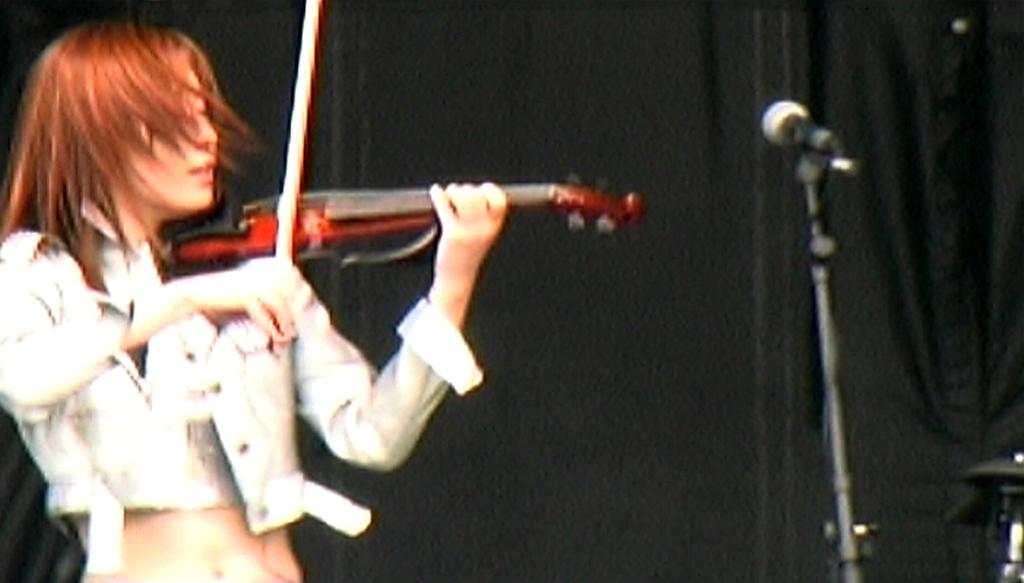What is the main subject of the image? There is a person in the image. Where is the person located in the image? The person is standing on the left side of the image. What is the person doing in the image? The person is playing a guitar. What can be seen on the right side of the image? There is a microphone (Mic) on the right side of the image. What is visible in the background of the image? There is a curtain in the background of the image. What type of office furniture can be seen in the image? There is no office furniture present in the image. Can you describe the pickle that is being used as a prop in the image? There is no pickle present in the image. 